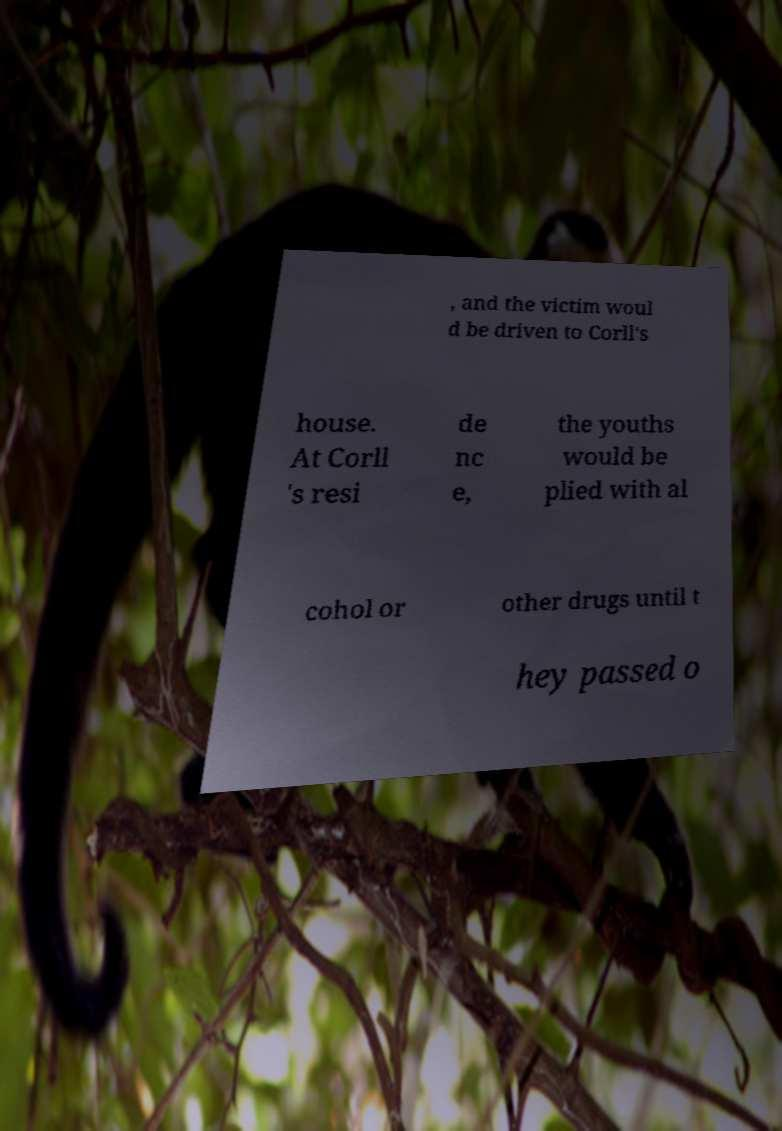Could you assist in decoding the text presented in this image and type it out clearly? , and the victim woul d be driven to Corll's house. At Corll 's resi de nc e, the youths would be plied with al cohol or other drugs until t hey passed o 